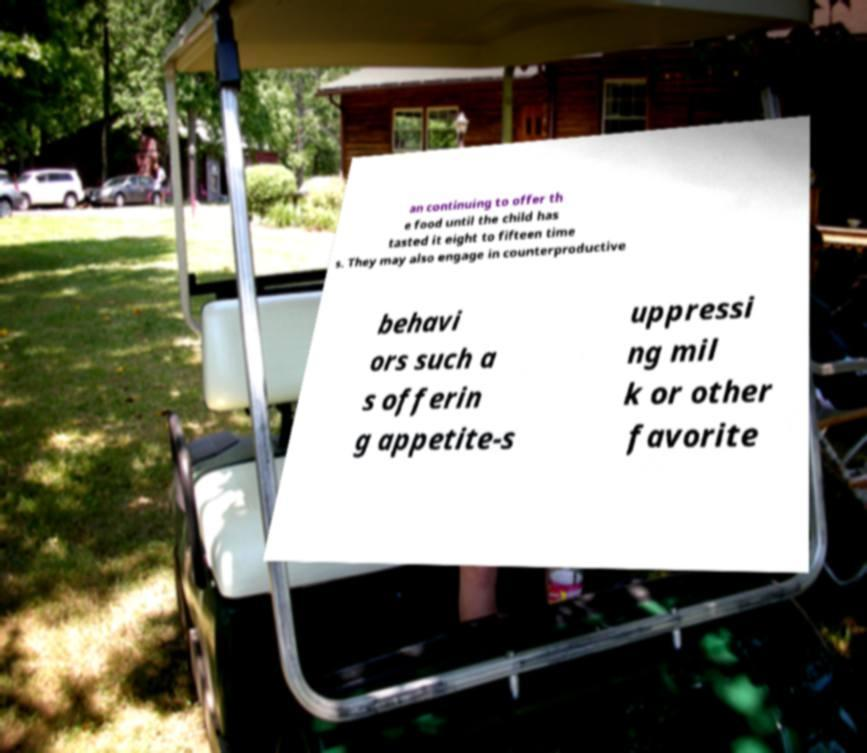Could you extract and type out the text from this image? an continuing to offer th e food until the child has tasted it eight to fifteen time s. They may also engage in counterproductive behavi ors such a s offerin g appetite-s uppressi ng mil k or other favorite 